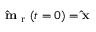Convert formula to latex. <formula><loc_0><loc_0><loc_500><loc_500>\hat { m } _ { r } ( t = 0 ) = \hat { x }</formula> 